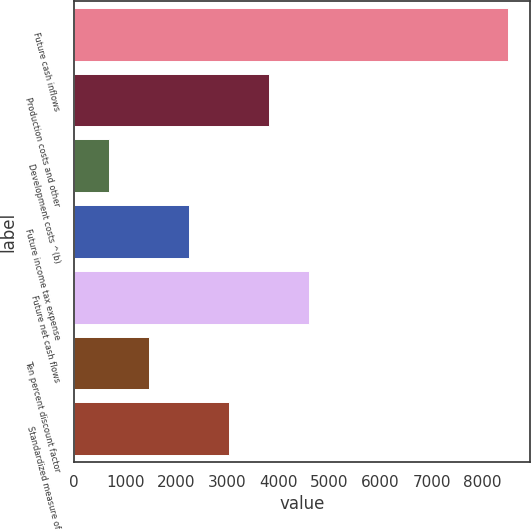<chart> <loc_0><loc_0><loc_500><loc_500><bar_chart><fcel>Future cash inflows<fcel>Production costs and other<fcel>Development costs ^(b)<fcel>Future income tax expense<fcel>Future net cash flows<fcel>Ten percent discount factor<fcel>Standardized measure of<nl><fcel>8494<fcel>3811<fcel>689<fcel>2250<fcel>4591.5<fcel>1469.5<fcel>3030.5<nl></chart> 